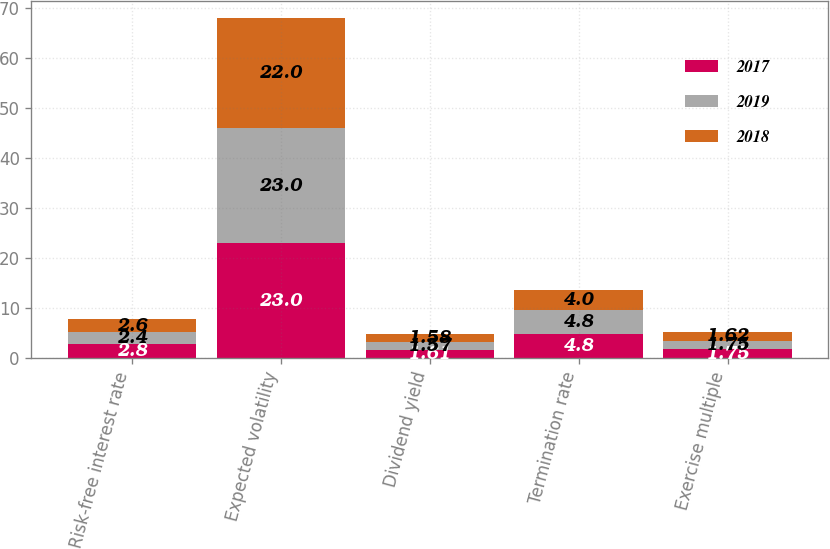<chart> <loc_0><loc_0><loc_500><loc_500><stacked_bar_chart><ecel><fcel>Risk-free interest rate<fcel>Expected volatility<fcel>Dividend yield<fcel>Termination rate<fcel>Exercise multiple<nl><fcel>2017<fcel>2.8<fcel>23<fcel>1.61<fcel>4.8<fcel>1.75<nl><fcel>2019<fcel>2.4<fcel>23<fcel>1.57<fcel>4.8<fcel>1.75<nl><fcel>2018<fcel>2.6<fcel>22<fcel>1.58<fcel>4<fcel>1.62<nl></chart> 